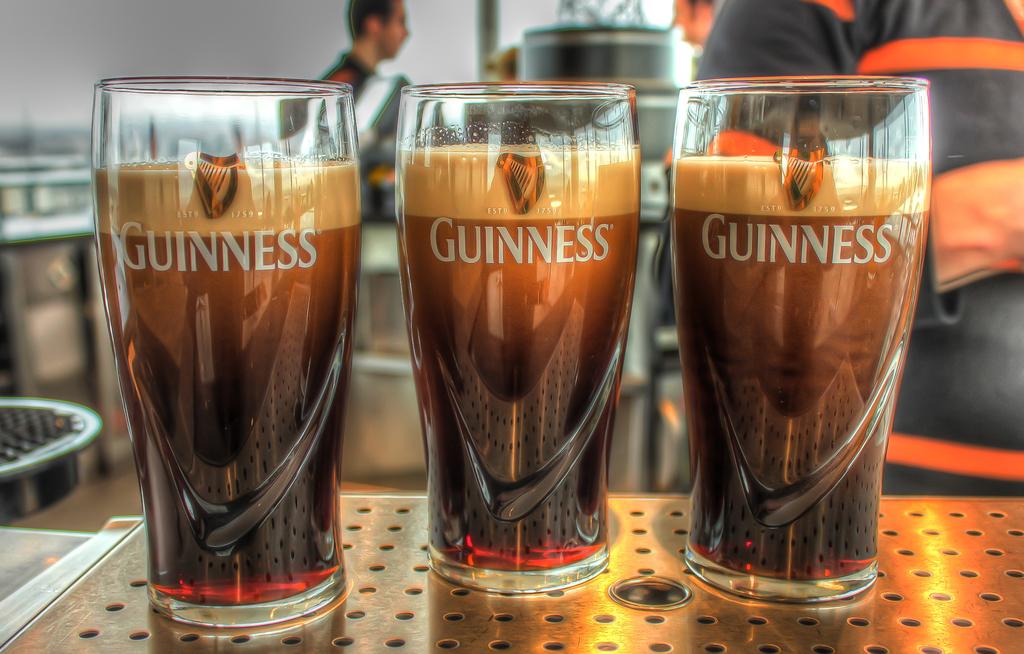What kind of beer is this?
Give a very brief answer. Guinness. What kind of beer is it?
Offer a very short reply. Guinness. 